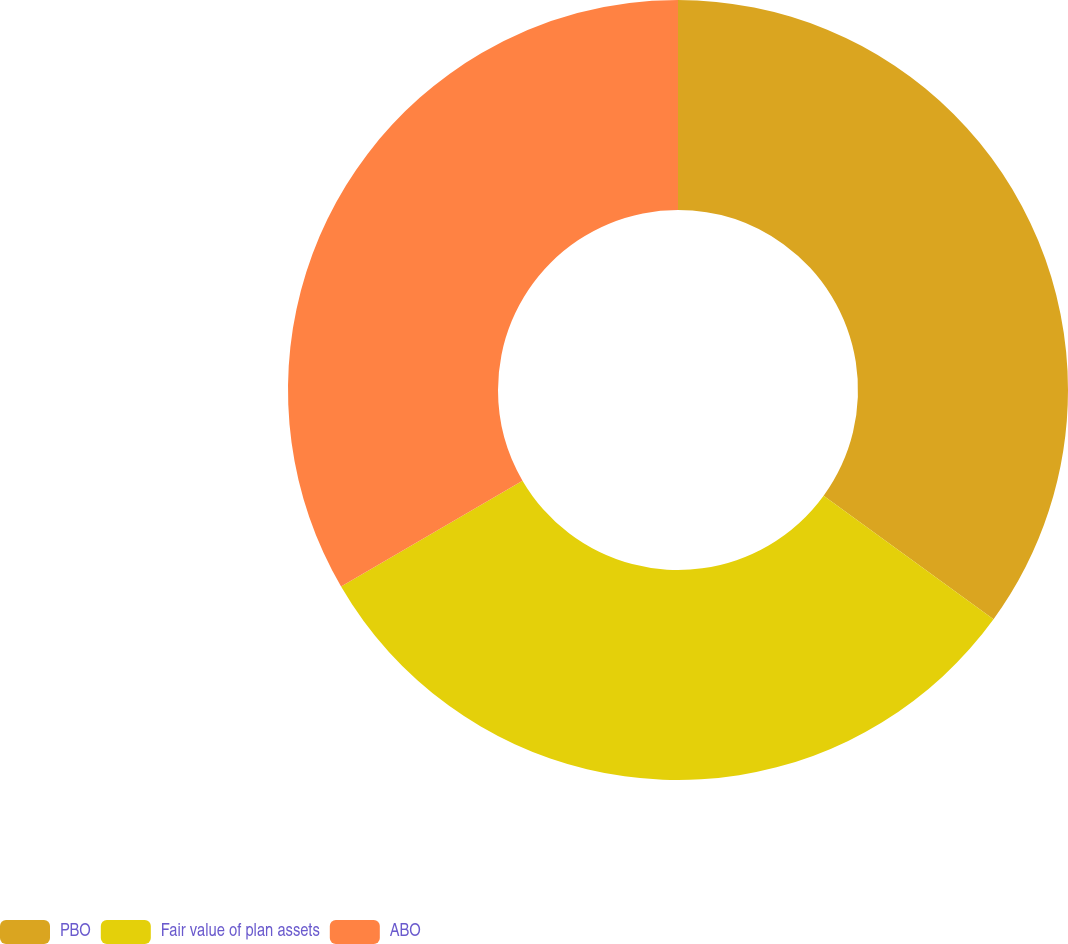<chart> <loc_0><loc_0><loc_500><loc_500><pie_chart><fcel>PBO<fcel>Fair value of plan assets<fcel>ABO<nl><fcel>35.0%<fcel>31.6%<fcel>33.4%<nl></chart> 